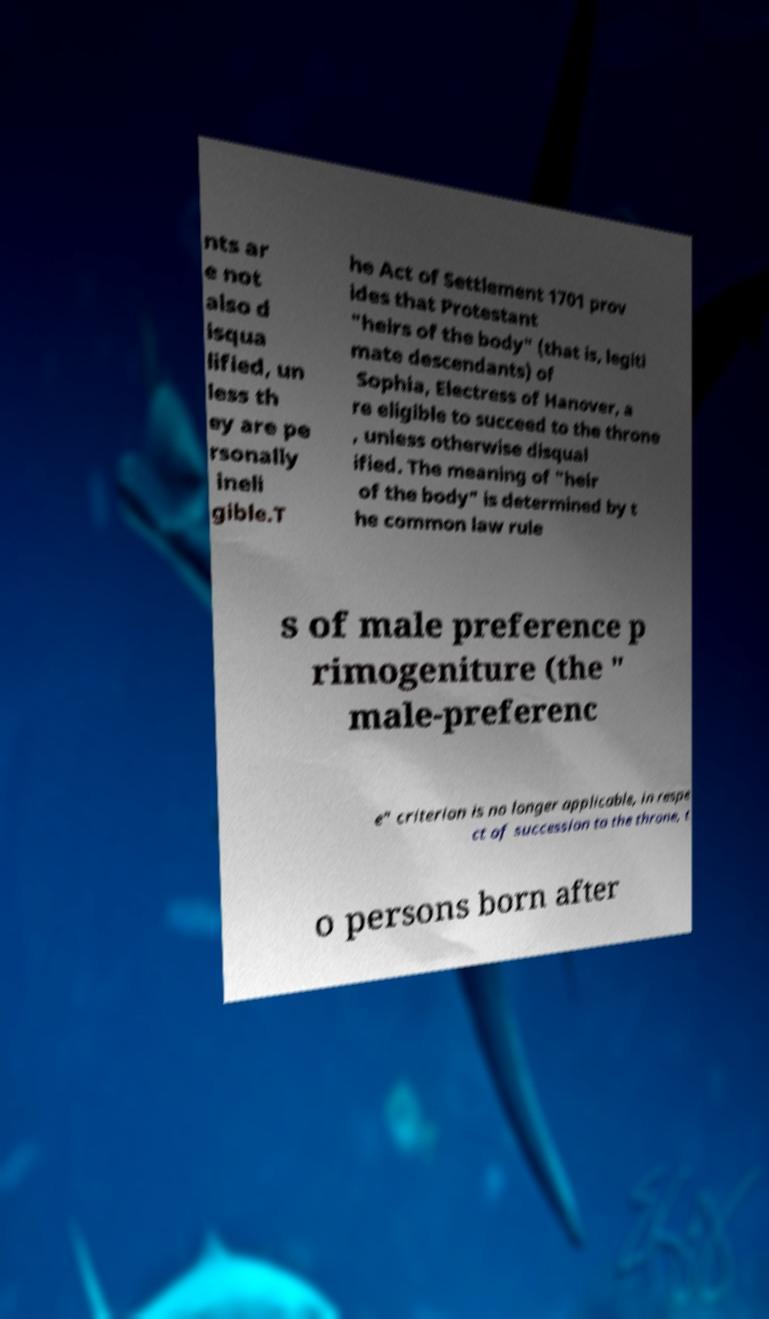There's text embedded in this image that I need extracted. Can you transcribe it verbatim? nts ar e not also d isqua lified, un less th ey are pe rsonally ineli gible.T he Act of Settlement 1701 prov ides that Protestant "heirs of the body" (that is, legiti mate descendants) of Sophia, Electress of Hanover, a re eligible to succeed to the throne , unless otherwise disqual ified. The meaning of "heir of the body" is determined by t he common law rule s of male preference p rimogeniture (the " male-preferenc e" criterion is no longer applicable, in respe ct of succession to the throne, t o persons born after 